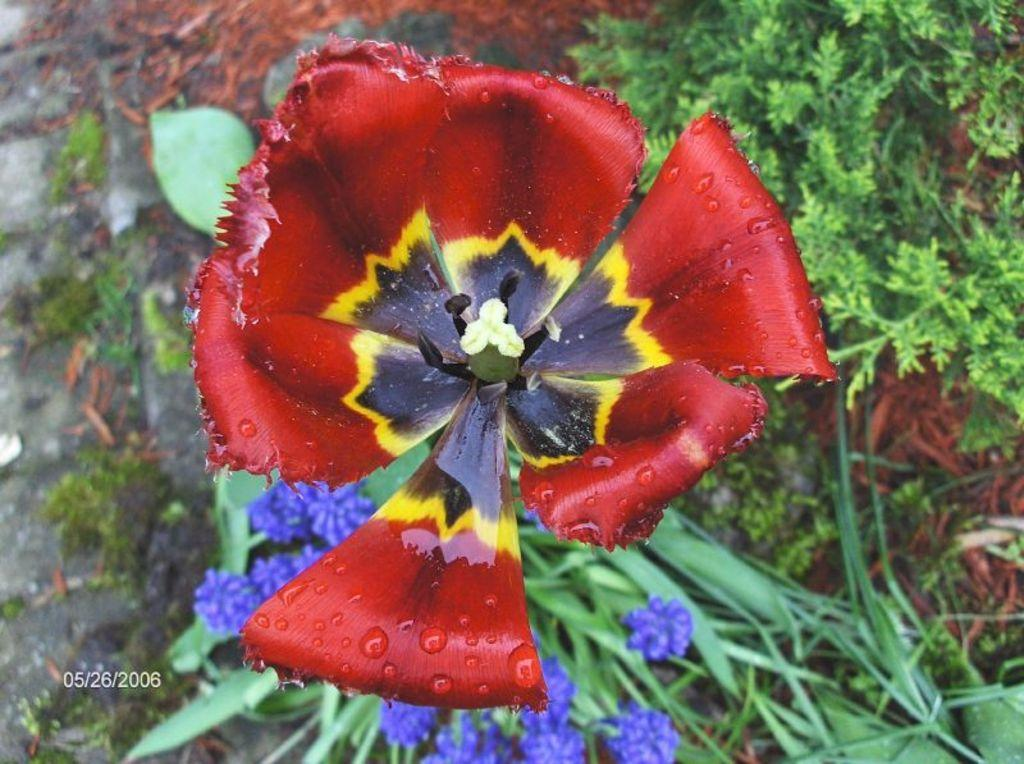What colors of flowers can be seen in the image? There is a red flower, a black flower, a yellow flower, a white flower, and purple flowers in the image. Are there any other types of plants visible in the image? Yes, there are green plants in the image. What type of farmer is shown taking care of the flowers in the image? There is no farmer present in the image; it only shows flowers and plants. 